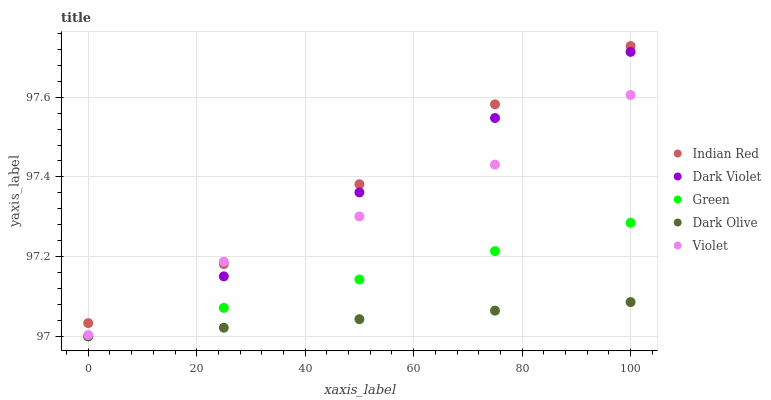Does Dark Olive have the minimum area under the curve?
Answer yes or no. Yes. Does Indian Red have the maximum area under the curve?
Answer yes or no. Yes. Does Green have the minimum area under the curve?
Answer yes or no. No. Does Green have the maximum area under the curve?
Answer yes or no. No. Is Dark Olive the smoothest?
Answer yes or no. Yes. Is Violet the roughest?
Answer yes or no. Yes. Is Green the smoothest?
Answer yes or no. No. Is Green the roughest?
Answer yes or no. No. Does Dark Olive have the lowest value?
Answer yes or no. Yes. Does Indian Red have the lowest value?
Answer yes or no. No. Does Indian Red have the highest value?
Answer yes or no. Yes. Does Green have the highest value?
Answer yes or no. No. Is Dark Olive less than Indian Red?
Answer yes or no. Yes. Is Violet greater than Green?
Answer yes or no. Yes. Does Dark Olive intersect Green?
Answer yes or no. Yes. Is Dark Olive less than Green?
Answer yes or no. No. Is Dark Olive greater than Green?
Answer yes or no. No. Does Dark Olive intersect Indian Red?
Answer yes or no. No. 